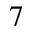<formula> <loc_0><loc_0><loc_500><loc_500>^ { 7 }</formula> 